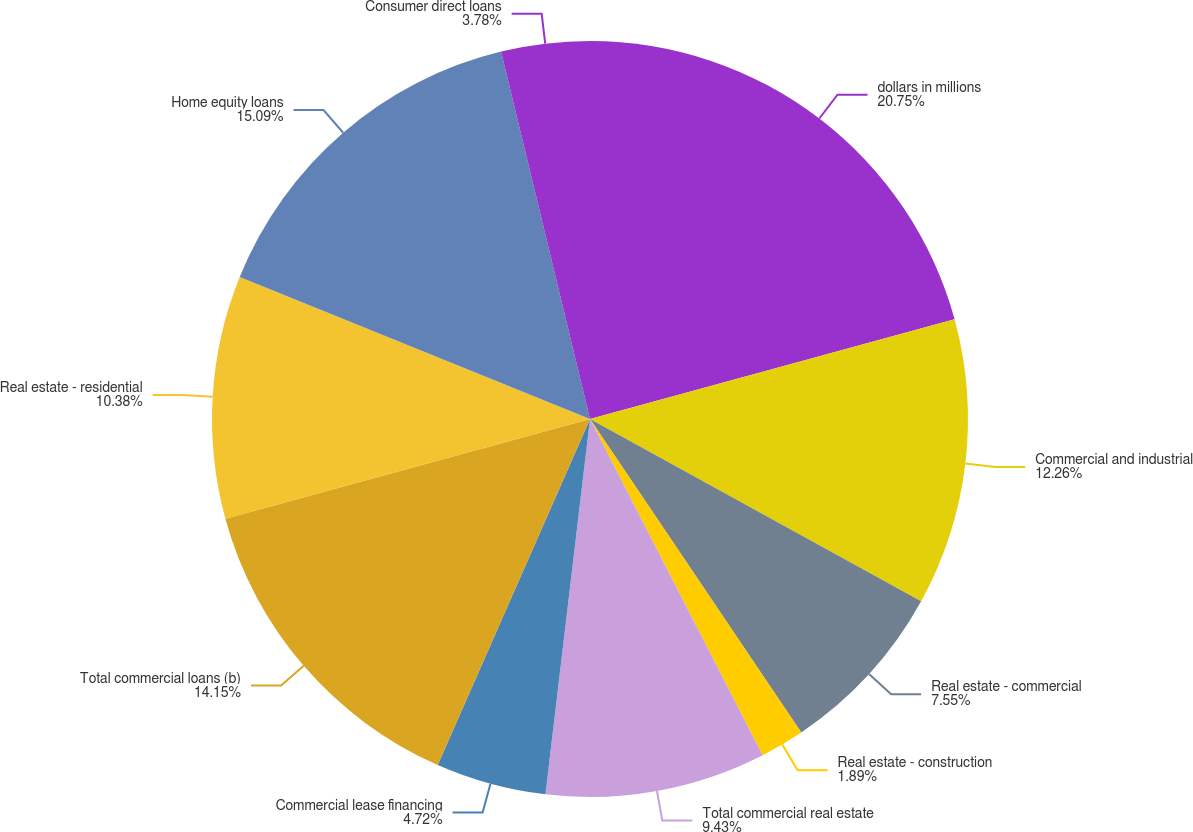Convert chart. <chart><loc_0><loc_0><loc_500><loc_500><pie_chart><fcel>dollars in millions<fcel>Commercial and industrial<fcel>Real estate - commercial<fcel>Real estate - construction<fcel>Total commercial real estate<fcel>Commercial lease financing<fcel>Total commercial loans (b)<fcel>Real estate - residential<fcel>Home equity loans<fcel>Consumer direct loans<nl><fcel>20.75%<fcel>12.26%<fcel>7.55%<fcel>1.89%<fcel>9.43%<fcel>4.72%<fcel>14.15%<fcel>10.38%<fcel>15.09%<fcel>3.78%<nl></chart> 